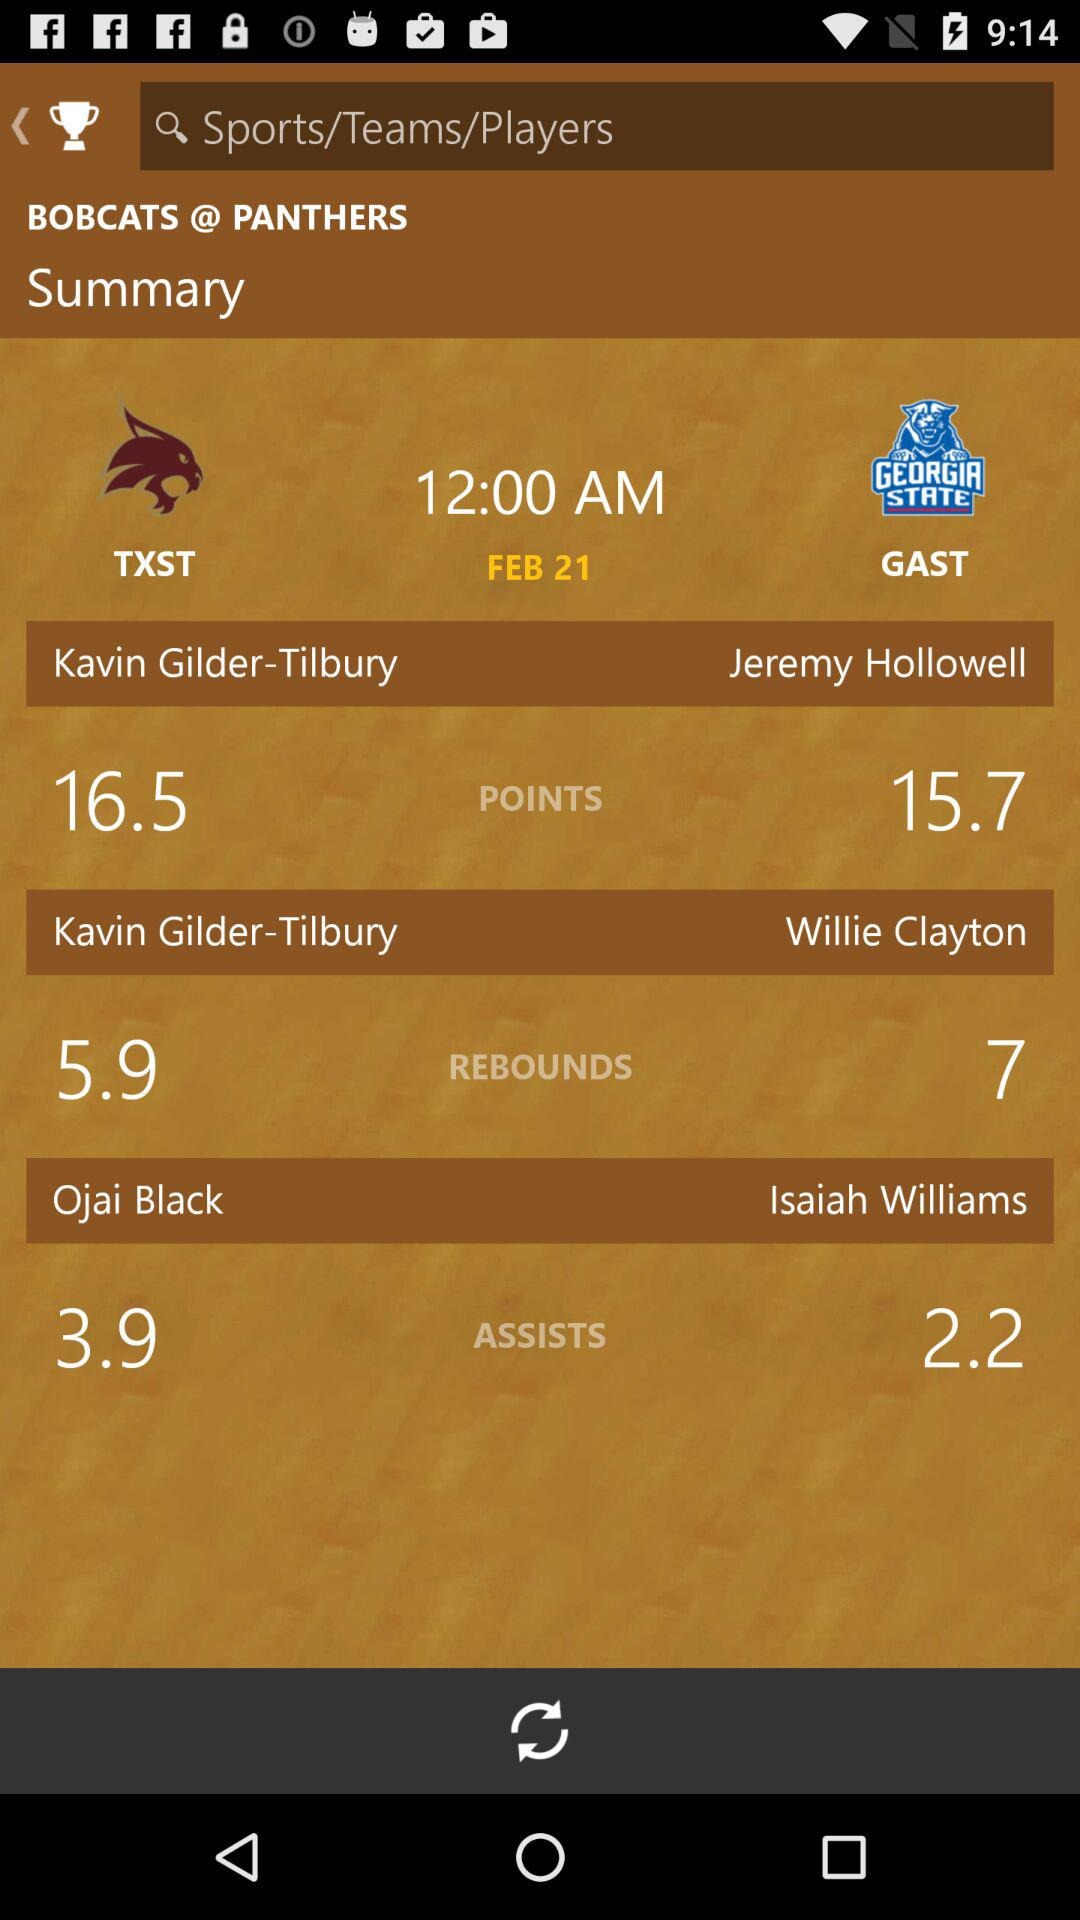Which player has an assist point of 3.9? The player is Ojai Black. 